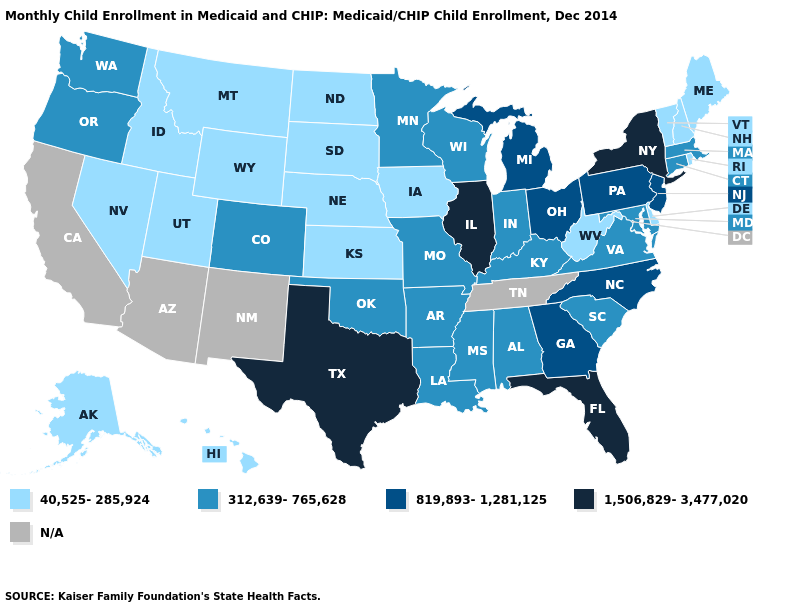What is the value of Missouri?
Concise answer only. 312,639-765,628. Does Utah have the lowest value in the USA?
Short answer required. Yes. Which states have the lowest value in the South?
Answer briefly. Delaware, West Virginia. What is the value of Ohio?
Write a very short answer. 819,893-1,281,125. What is the lowest value in the MidWest?
Quick response, please. 40,525-285,924. Among the states that border California , does Nevada have the lowest value?
Be succinct. Yes. What is the value of North Dakota?
Be succinct. 40,525-285,924. Name the states that have a value in the range 312,639-765,628?
Quick response, please. Alabama, Arkansas, Colorado, Connecticut, Indiana, Kentucky, Louisiana, Maryland, Massachusetts, Minnesota, Mississippi, Missouri, Oklahoma, Oregon, South Carolina, Virginia, Washington, Wisconsin. How many symbols are there in the legend?
Be succinct. 5. Which states have the lowest value in the USA?
Be succinct. Alaska, Delaware, Hawaii, Idaho, Iowa, Kansas, Maine, Montana, Nebraska, Nevada, New Hampshire, North Dakota, Rhode Island, South Dakota, Utah, Vermont, West Virginia, Wyoming. What is the value of Colorado?
Write a very short answer. 312,639-765,628. Among the states that border Delaware , which have the highest value?
Write a very short answer. New Jersey, Pennsylvania. Name the states that have a value in the range 312,639-765,628?
Answer briefly. Alabama, Arkansas, Colorado, Connecticut, Indiana, Kentucky, Louisiana, Maryland, Massachusetts, Minnesota, Mississippi, Missouri, Oklahoma, Oregon, South Carolina, Virginia, Washington, Wisconsin. Does Virginia have the highest value in the USA?
Give a very brief answer. No. Which states have the highest value in the USA?
Give a very brief answer. Florida, Illinois, New York, Texas. 